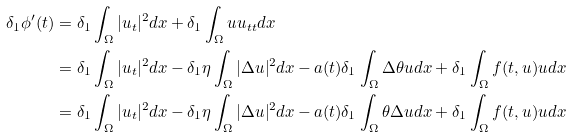<formula> <loc_0><loc_0><loc_500><loc_500>\delta _ { 1 } \phi ^ { \prime } ( t ) & = \delta _ { 1 } \int _ { \Omega } | u _ { t } | ^ { 2 } d x + \delta _ { 1 } \int _ { \Omega } u u _ { t t } d x \\ & = \delta _ { 1 } \int _ { \Omega } | u _ { t } | ^ { 2 } d x - \delta _ { 1 } \eta \int _ { \Omega } | \Delta u | ^ { 2 } d x - a ( t ) \delta _ { 1 } \int _ { \Omega } \Delta \theta u d x + \delta _ { 1 } \int _ { \Omega } f ( t , u ) u d x \\ & = \delta _ { 1 } \int _ { \Omega } | u _ { t } | ^ { 2 } d x - \delta _ { 1 } \eta \int _ { \Omega } | \Delta u | ^ { 2 } d x - a ( t ) \delta _ { 1 } \int _ { \Omega } \theta \Delta u d x + \delta _ { 1 } \int _ { \Omega } f ( t , u ) u d x</formula> 